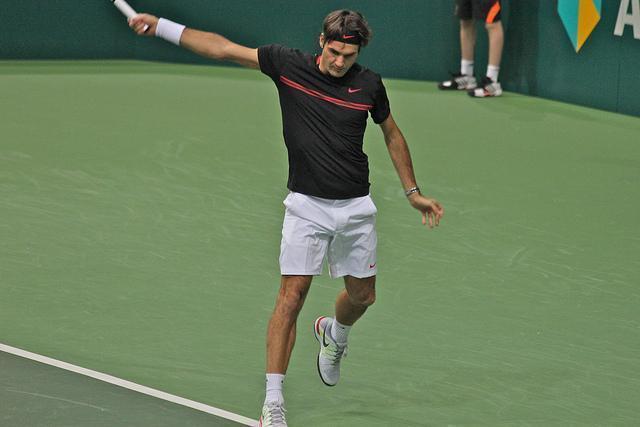What is the man in the foreground wearing on his feet?
Choose the correct response, then elucidate: 'Answer: answer
Rationale: rationale.'
Options: Sandals, sneakers, boots, shoes. Answer: sneakers.
Rationale: These are tennis shoes to keep feet comfortable 